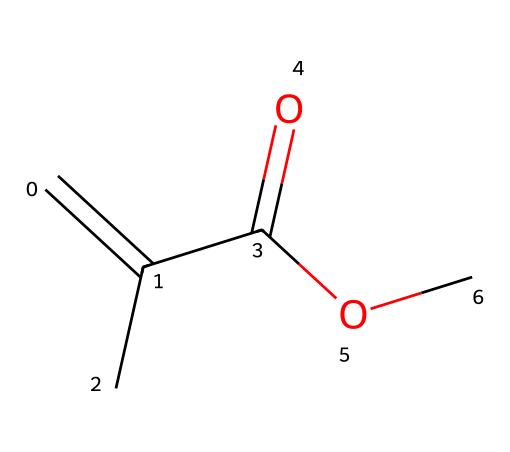What is the name of the compound represented by this SMILES? The SMILES notation "C=C(C)C(=O)OC" indicates it is an acrylic ester based on the structure. Specifically, it corresponds to methyl methacrylate.
Answer: methyl methacrylate How many carbon atoms are in the structure? By analyzing the SMILES, there are five carbon atoms present: three from the main chain and two from the methyl groups.
Answer: five What type of functional group is present in this molecule? The structure features a carboxylate ester functional group (as indicated by the "C(=O)OC" portion of the SMILES).
Answer: ester How many double bonds are present in the molecule? The SMILES "C=C(C)" clearly shows a double bond between the first two carbon atoms, indicating there is one double bond in the structure.
Answer: one What is the degree of substitution around the double bond? The presence of the methyl group attached to one of the carbon atoms in the double bond indicates it has a branched structure, indicating it is monosubstituted.
Answer: monosubstituted Is this molecule a monomer or a polymer? The structure represents a monomer, specifically used in the formation of polymers like acrylic resins, as it contains a double bond conducive to polymerization.
Answer: monomer 